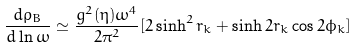<formula> <loc_0><loc_0><loc_500><loc_500>\frac { d \rho _ { B } } { d \ln { \omega } } \simeq \frac { g ^ { 2 } ( \eta ) \omega ^ { 4 } } { 2 \pi ^ { 2 } } [ 2 \sinh ^ { 2 } { r _ { k } } + \sinh { 2 r _ { k } } \cos { 2 \phi _ { k } } ]</formula> 